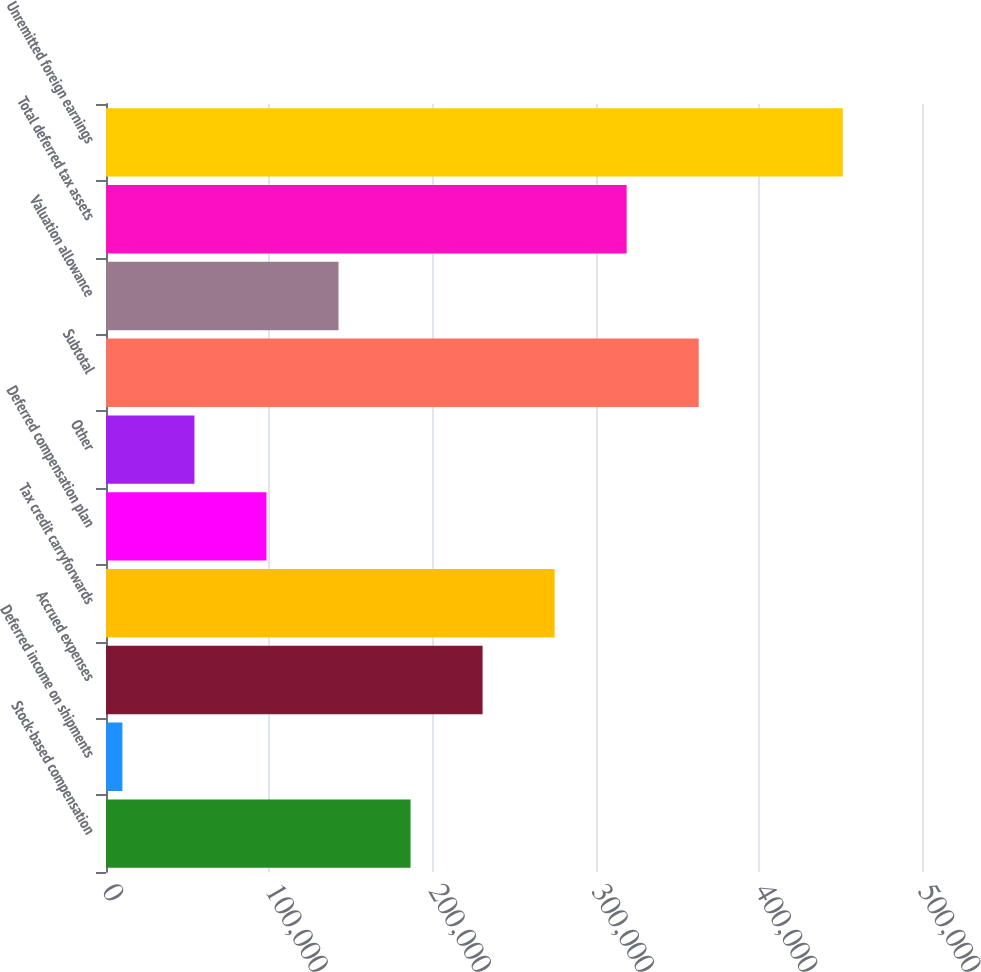Convert chart. <chart><loc_0><loc_0><loc_500><loc_500><bar_chart><fcel>Stock-based compensation<fcel>Deferred income on shipments<fcel>Accrued expenses<fcel>Tax credit carryforwards<fcel>Deferred compensation plan<fcel>Other<fcel>Subtotal<fcel>Valuation allowance<fcel>Total deferred tax assets<fcel>Unremitted foreign earnings<nl><fcel>186612<fcel>10043<fcel>230754<fcel>274896<fcel>98327.4<fcel>54185.2<fcel>363181<fcel>142470<fcel>319038<fcel>451465<nl></chart> 